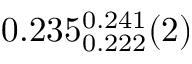<formula> <loc_0><loc_0><loc_500><loc_500>0 . 2 3 5 _ { 0 . 2 2 2 } ^ { 0 . 2 4 1 } ( 2 )</formula> 